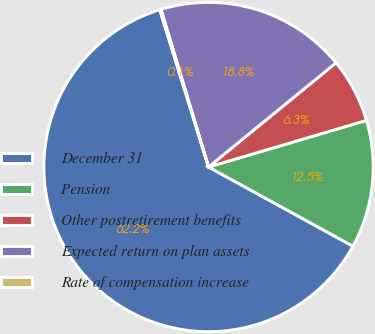Convert chart. <chart><loc_0><loc_0><loc_500><loc_500><pie_chart><fcel>December 31<fcel>Pension<fcel>Other postretirement benefits<fcel>Expected return on plan assets<fcel>Rate of compensation increase<nl><fcel>62.24%<fcel>12.55%<fcel>6.34%<fcel>18.76%<fcel>0.12%<nl></chart> 